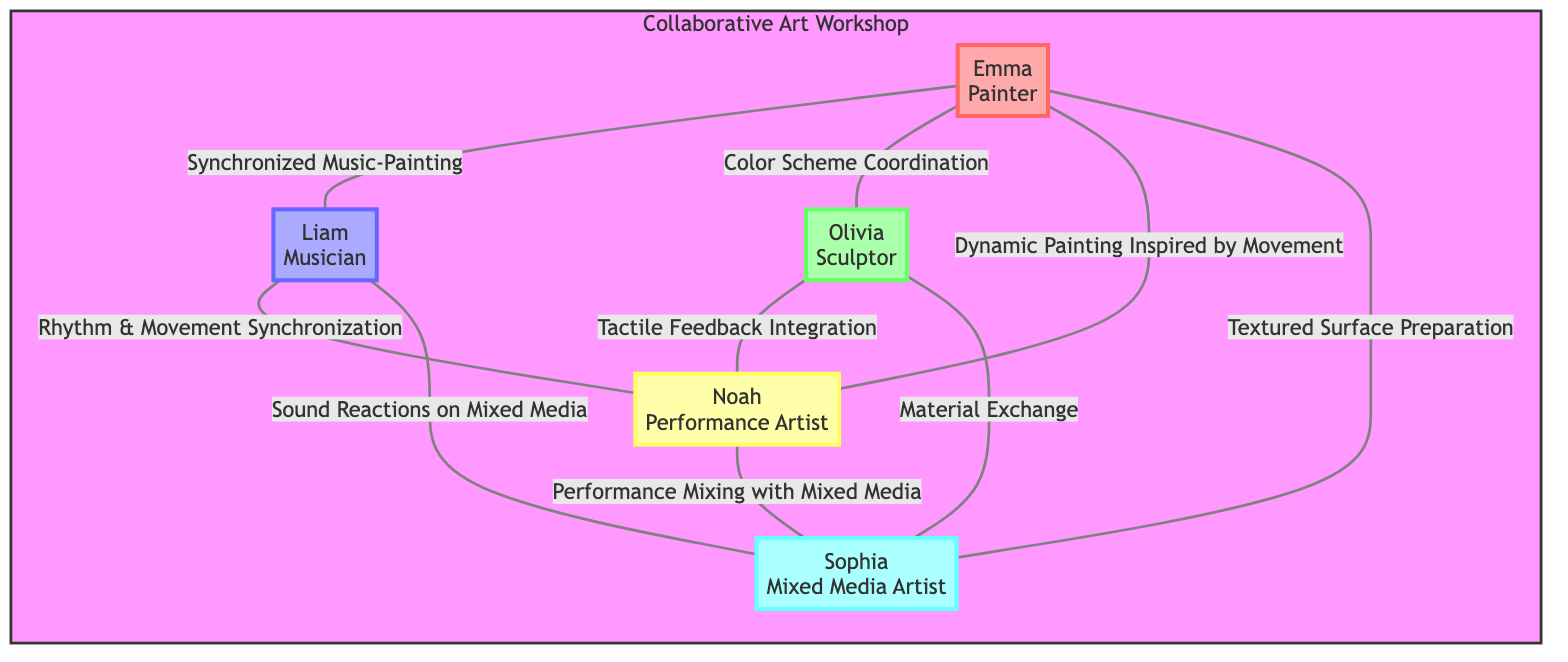What is the total number of participants in the workshop? The diagram lists 5 nodes representing participants in the Collaborative Art Workshop: Emma, Liam, Olivia, Noah, and Sophia. Counting these nodes gives a total of 5 participants.
Answer: 5 Who collaborates with Emma on Color Scheme Coordination? The edge labeled "Color Scheme Coordination" leads from Emma to Olivia, indicating that Olivia collaborates with Emma on this interaction.
Answer: Olivia What type of interaction does Noah have with Sophia? The edge labeled "Performance Mixing with Mixed Media" connects Noah to Sophia, defining the interaction type as Performance Mixing with Mixed Media.
Answer: Performance Mixing with Mixed Media Which participant has the most interactions, and how many are there? Upon evaluating the edges, Emma interacts with 4 different participants (Liam, Olivia, Noah, and Sophia), more than any other participant. Therefore, Emma has the most interactions, totaling 4.
Answer: Emma, 4 How many interactions involve mixed media in the workshop? There are 3 edges that mention mixed media: "Sound Reactions on Mixed Media" (Liam to Sophia), "Textured Surface Preparation" (Emma to Sophia), and "Performance Mixing with Mixed Media" (Noah to Sophia). Counting these gives a total of 3 mixed media interactions.
Answer: 3 Which two participants exchange materials? The edge labeled "Material Exchange" connects Olivia and Sophia, indicating that these two participants exchange materials with one another.
Answer: Olivia and Sophia What role does Liam play in relation to Noah? The edge between Liam and Noah is marked "Rhythm & Movement Synchronization," indicating that Liam, as a Musician, synchronizes rhythm and movement with Noah, a Performance Artist.
Answer: Musician Which interaction is linked to tactile feedback? The edge labeled "Tactile Feedback Integration" connects Olivia and Noah, indicating this interaction is specifically linked to tactile feedback.
Answer: Tactile Feedback Integration 